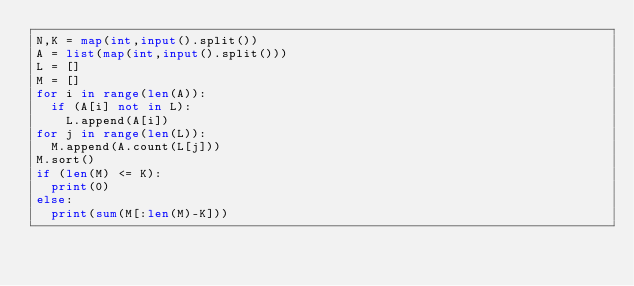<code> <loc_0><loc_0><loc_500><loc_500><_Python_>N,K = map(int,input().split())
A = list(map(int,input().split()))
L = []
M = []
for i in range(len(A)):
  if (A[i] not in L):
    L.append(A[i])
for j in range(len(L)):
  M.append(A.count(L[j]))
M.sort()
if (len(M) <= K):
  print(0)
else:
  print(sum(M[:len(M)-K]))</code> 